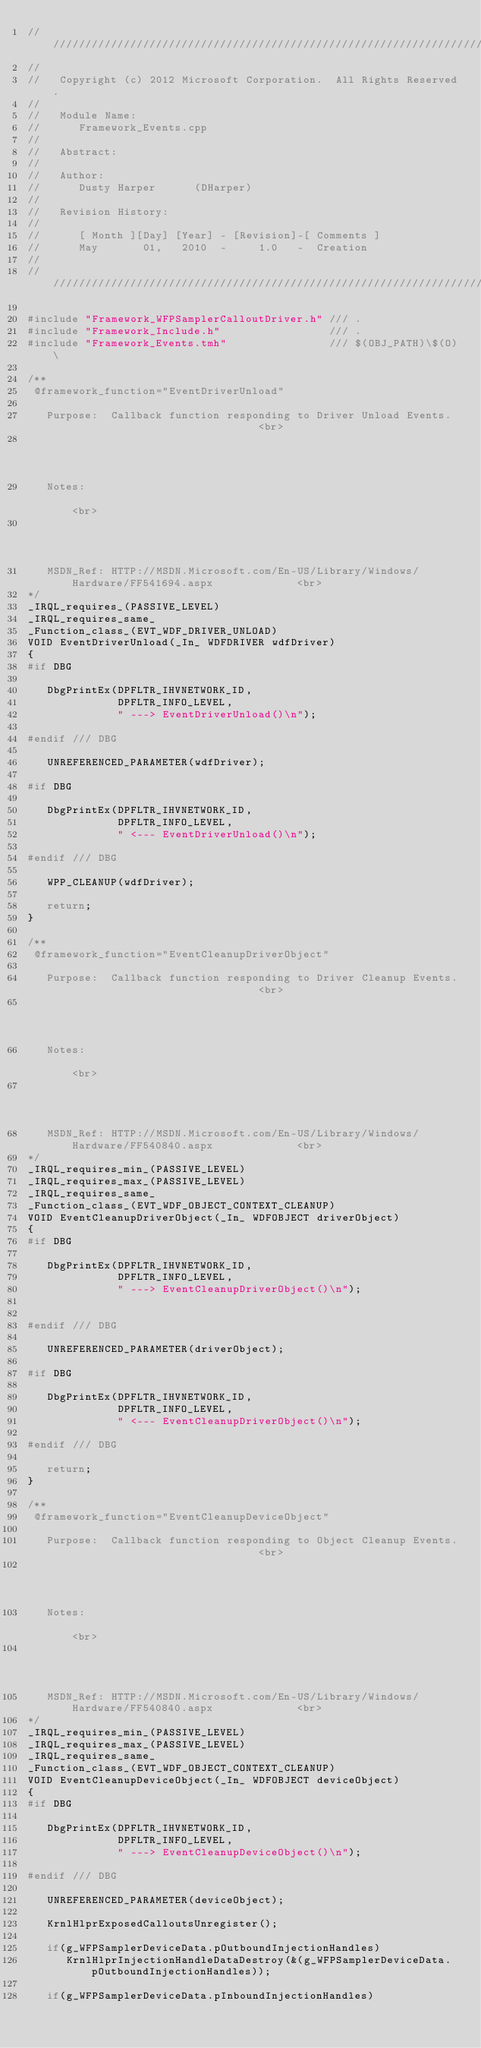<code> <loc_0><loc_0><loc_500><loc_500><_C++_>////////////////////////////////////////////////////////////////////////////////////////////////////
//
//   Copyright (c) 2012 Microsoft Corporation.  All Rights Reserved.
//
//   Module Name:
//      Framework_Events.cpp
//
//   Abstract:
//
//   Author:
//      Dusty Harper      (DHarper)
//
//   Revision History:
//
//      [ Month ][Day] [Year] - [Revision]-[ Comments ]
//      May       01,   2010  -     1.0   -  Creation
//
////////////////////////////////////////////////////////////////////////////////////////////////////

#include "Framework_WFPSamplerCalloutDriver.h" /// .
#include "Framework_Include.h"                 /// .
#include "Framework_Events.tmh"                /// $(OBJ_PATH)\$(O)\

/**
 @framework_function="EventDriverUnload"
 
   Purpose:  Callback function responding to Driver Unload Events.                              <br>
                                                                                                <br>
   Notes:                                                                                       <br>
                                                                                                <br>
   MSDN_Ref: HTTP://MSDN.Microsoft.com/En-US/Library/Windows/Hardware/FF541694.aspx             <br>
*/
_IRQL_requires_(PASSIVE_LEVEL)
_IRQL_requires_same_
_Function_class_(EVT_WDF_DRIVER_UNLOAD)
VOID EventDriverUnload(_In_ WDFDRIVER wdfDriver)
{
#if DBG
   
   DbgPrintEx(DPFLTR_IHVNETWORK_ID,
              DPFLTR_INFO_LEVEL,
              " ---> EventDriverUnload()\n");

#endif /// DBG
   
   UNREFERENCED_PARAMETER(wdfDriver);

#if DBG
   
   DbgPrintEx(DPFLTR_IHVNETWORK_ID,
              DPFLTR_INFO_LEVEL,
              " <--- EventDriverUnload()\n");

#endif /// DBG
   
   WPP_CLEANUP(wdfDriver);

   return;
}

/**
 @framework_function="EventCleanupDriverObject"
 
   Purpose:  Callback function responding to Driver Cleanup Events.                             <br>
                                                                                                <br>
   Notes:                                                                                       <br>
                                                                                                <br>
   MSDN_Ref: HTTP://MSDN.Microsoft.com/En-US/Library/Windows/Hardware/FF540840.aspx             <br>
*/
_IRQL_requires_min_(PASSIVE_LEVEL)
_IRQL_requires_max_(PASSIVE_LEVEL)
_IRQL_requires_same_
_Function_class_(EVT_WDF_OBJECT_CONTEXT_CLEANUP)
VOID EventCleanupDriverObject(_In_ WDFOBJECT driverObject)
{
#if DBG
   
   DbgPrintEx(DPFLTR_IHVNETWORK_ID,
              DPFLTR_INFO_LEVEL,
              " ---> EventCleanupDriverObject()\n");


#endif /// DBG
   
   UNREFERENCED_PARAMETER(driverObject);

#if DBG
   
   DbgPrintEx(DPFLTR_IHVNETWORK_ID,
              DPFLTR_INFO_LEVEL,
              " <--- EventCleanupDriverObject()\n");

#endif /// DBG
   
   return;
}

/**
 @framework_function="EventCleanupDeviceObject"
 
   Purpose:  Callback function responding to Object Cleanup Events.                             <br>
                                                                                                <br>
   Notes:                                                                                       <br>
                                                                                                <br>
   MSDN_Ref: HTTP://MSDN.Microsoft.com/En-US/Library/Windows/Hardware/FF540840.aspx             <br>
*/
_IRQL_requires_min_(PASSIVE_LEVEL)
_IRQL_requires_max_(PASSIVE_LEVEL)
_IRQL_requires_same_
_Function_class_(EVT_WDF_OBJECT_CONTEXT_CLEANUP)
VOID EventCleanupDeviceObject(_In_ WDFOBJECT deviceObject)
{
#if DBG
   
   DbgPrintEx(DPFLTR_IHVNETWORK_ID,
              DPFLTR_INFO_LEVEL,
              " ---> EventCleanupDeviceObject()\n");

#endif /// DBG
   
   UNREFERENCED_PARAMETER(deviceObject);

   KrnlHlprExposedCalloutsUnregister();

   if(g_WFPSamplerDeviceData.pOutboundInjectionHandles)
      KrnlHlprInjectionHandleDataDestroy(&(g_WFPSamplerDeviceData.pOutboundInjectionHandles));

   if(g_WFPSamplerDeviceData.pInboundInjectionHandles)</code> 